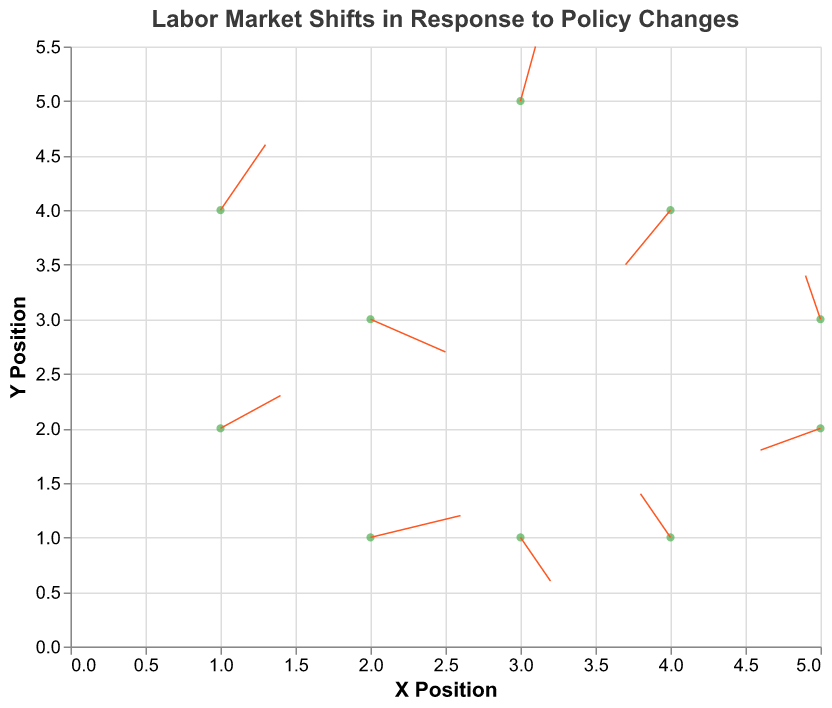What's the title of the figure? The title of the figure is displayed clearly at the top.
Answer: Labor Market Shifts in Response to Policy Changes How many policy changes are depicted in the figure? Each policy change is represented by an arrow, and we can count these arrows in the figure. There are 10 arrows, each representing a different policy change.
Answer: 10 Which policy change corresponds to the arrow starting at (4, 1)? By checking the coordinates and matching them with the given data, the arrow starting at (4, 1) is related to "Job Training Programs".
Answer: Job Training Programs What is the direction of the velocity vector for "Healthcare Reform"? Examine the coordinates and values for "Healthcare Reform", where u = -0.1 and v = 0.4, meaning the arrow points to the left and slightly upwards.
Answer: Left and Upwards Which policy change shows the largest positive shift in the x-direction? By comparing the u values across all policies, "Immigration Policy Changes" has the largest positive shift in the x-direction with u = 0.6.
Answer: Immigration Policy Changes Which two policies have opposite shifts in both the x and y directions? Opposite shifts in x and y directions mean one policy has positive u and v while the other has negative u and v. "Education Funding Increase" (u = 0.4, v = 0.3) and "Trade Agreement Modifications" (u = -0.3, v = -0.5) fulfill this condition.
Answer: Education Funding Increase and Trade Agreement Modifications What are the start and end points for the arrow representing "Remote Work Regulations"? The start point is given by (3, 5). The end point can be calculated by adding u and v to the start point: (3 + 0.1, 5 + 0.5) = (3.1, 5.5).
Answer: Start: (3, 5), End: (3.1, 5.5) Which policy change results in the smallest magnitude of shift, and what is that magnitude? Calculate the magnitude for each policy with sqrt(u^2 + v^2). The smallest magnitude shift is for "Minimum Wage Increase" with u = 0.5 and v = -0.3: sqrt(0.5^2 + (-0.3)^2) = sqrt(0.25 + 0.09) = sqrt(0.34) ≈ 0.583.
Answer: Minimum Wage Increase, ≈ 0.583 If we average the horizontal shifts (u values) and vertical shifts (v values) across all policies, what are the results? Sum all u values: 0.5 + (-0.2) + 0.3 - 0.4 + 0.1 + 0.6 - 0.3 + 0.4 - 0.1 + 0.2 = 1.1. Sum all v values: -0.3 + 0.4 + 0.6 - 0.2 + 0.5 + 0.2 - 0.5 + 0.3 + 0.4 - 0.4 = 1.0. Average horizontal shift: 1.1 / 10 = 0.11. Average vertical shift: 1.0 / 10 = 0.1.
Answer: Horizontal: 0.11, Vertical: 0.1 